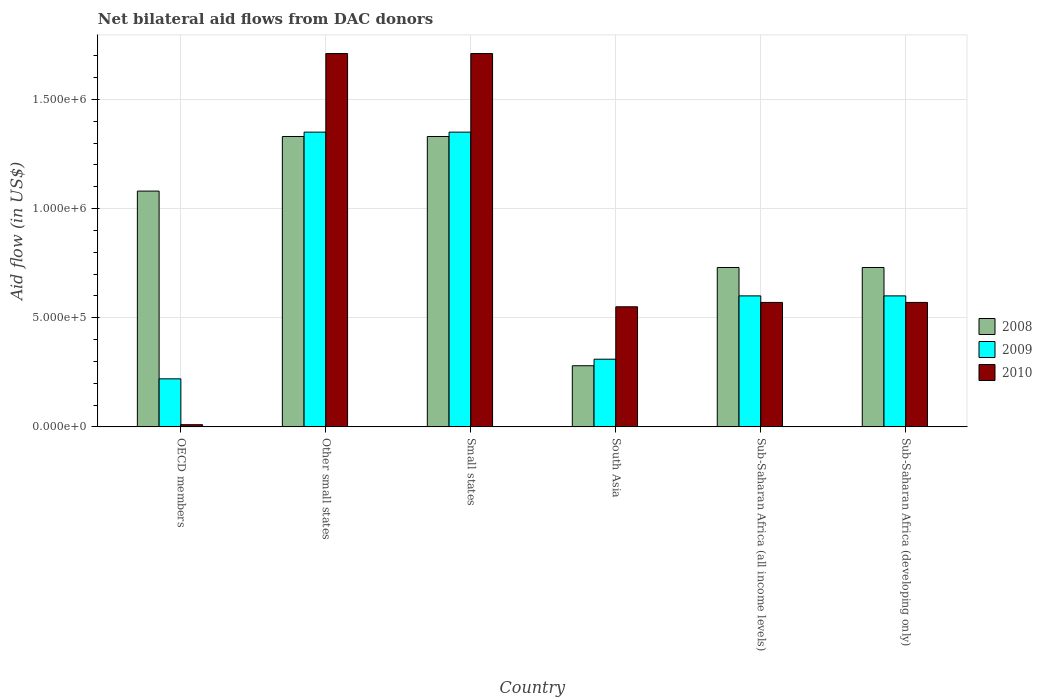How many different coloured bars are there?
Provide a succinct answer. 3. Are the number of bars per tick equal to the number of legend labels?
Offer a very short reply. Yes. How many bars are there on the 2nd tick from the right?
Keep it short and to the point. 3. What is the label of the 4th group of bars from the left?
Provide a succinct answer. South Asia. In how many cases, is the number of bars for a given country not equal to the number of legend labels?
Your response must be concise. 0. What is the net bilateral aid flow in 2008 in Small states?
Offer a very short reply. 1.33e+06. Across all countries, what is the maximum net bilateral aid flow in 2009?
Offer a very short reply. 1.35e+06. In which country was the net bilateral aid flow in 2008 maximum?
Your answer should be compact. Other small states. What is the total net bilateral aid flow in 2010 in the graph?
Keep it short and to the point. 5.12e+06. What is the difference between the net bilateral aid flow in 2010 in Other small states and that in Sub-Saharan Africa (all income levels)?
Provide a short and direct response. 1.14e+06. What is the difference between the net bilateral aid flow in 2010 in Sub-Saharan Africa (all income levels) and the net bilateral aid flow in 2009 in South Asia?
Your response must be concise. 2.60e+05. What is the average net bilateral aid flow in 2010 per country?
Your response must be concise. 8.53e+05. What is the difference between the net bilateral aid flow of/in 2010 and net bilateral aid flow of/in 2008 in Sub-Saharan Africa (developing only)?
Provide a short and direct response. -1.60e+05. In how many countries, is the net bilateral aid flow in 2010 greater than 1300000 US$?
Give a very brief answer. 2. What is the ratio of the net bilateral aid flow in 2010 in OECD members to that in Sub-Saharan Africa (developing only)?
Ensure brevity in your answer.  0.02. Is the difference between the net bilateral aid flow in 2010 in Small states and Sub-Saharan Africa (developing only) greater than the difference between the net bilateral aid flow in 2008 in Small states and Sub-Saharan Africa (developing only)?
Offer a very short reply. Yes. What is the difference between the highest and the second highest net bilateral aid flow in 2010?
Make the answer very short. 1.14e+06. What is the difference between the highest and the lowest net bilateral aid flow in 2009?
Keep it short and to the point. 1.13e+06. Is the sum of the net bilateral aid flow in 2010 in OECD members and Other small states greater than the maximum net bilateral aid flow in 2009 across all countries?
Make the answer very short. Yes. What does the 3rd bar from the left in South Asia represents?
Your answer should be very brief. 2010. What does the 3rd bar from the right in OECD members represents?
Provide a succinct answer. 2008. Does the graph contain grids?
Provide a short and direct response. Yes. Where does the legend appear in the graph?
Your answer should be compact. Center right. How many legend labels are there?
Give a very brief answer. 3. What is the title of the graph?
Offer a terse response. Net bilateral aid flows from DAC donors. What is the label or title of the X-axis?
Your response must be concise. Country. What is the label or title of the Y-axis?
Provide a succinct answer. Aid flow (in US$). What is the Aid flow (in US$) of 2008 in OECD members?
Keep it short and to the point. 1.08e+06. What is the Aid flow (in US$) of 2009 in OECD members?
Provide a short and direct response. 2.20e+05. What is the Aid flow (in US$) in 2010 in OECD members?
Keep it short and to the point. 10000. What is the Aid flow (in US$) in 2008 in Other small states?
Provide a short and direct response. 1.33e+06. What is the Aid flow (in US$) of 2009 in Other small states?
Ensure brevity in your answer.  1.35e+06. What is the Aid flow (in US$) in 2010 in Other small states?
Give a very brief answer. 1.71e+06. What is the Aid flow (in US$) of 2008 in Small states?
Your answer should be compact. 1.33e+06. What is the Aid flow (in US$) in 2009 in Small states?
Offer a very short reply. 1.35e+06. What is the Aid flow (in US$) in 2010 in Small states?
Keep it short and to the point. 1.71e+06. What is the Aid flow (in US$) in 2009 in South Asia?
Keep it short and to the point. 3.10e+05. What is the Aid flow (in US$) in 2008 in Sub-Saharan Africa (all income levels)?
Give a very brief answer. 7.30e+05. What is the Aid flow (in US$) in 2010 in Sub-Saharan Africa (all income levels)?
Your response must be concise. 5.70e+05. What is the Aid flow (in US$) of 2008 in Sub-Saharan Africa (developing only)?
Your answer should be compact. 7.30e+05. What is the Aid flow (in US$) of 2009 in Sub-Saharan Africa (developing only)?
Your response must be concise. 6.00e+05. What is the Aid flow (in US$) of 2010 in Sub-Saharan Africa (developing only)?
Your answer should be compact. 5.70e+05. Across all countries, what is the maximum Aid flow (in US$) in 2008?
Provide a succinct answer. 1.33e+06. Across all countries, what is the maximum Aid flow (in US$) in 2009?
Your answer should be very brief. 1.35e+06. Across all countries, what is the maximum Aid flow (in US$) of 2010?
Provide a short and direct response. 1.71e+06. Across all countries, what is the minimum Aid flow (in US$) in 2009?
Ensure brevity in your answer.  2.20e+05. Across all countries, what is the minimum Aid flow (in US$) in 2010?
Provide a succinct answer. 10000. What is the total Aid flow (in US$) of 2008 in the graph?
Provide a short and direct response. 5.48e+06. What is the total Aid flow (in US$) in 2009 in the graph?
Provide a short and direct response. 4.43e+06. What is the total Aid flow (in US$) in 2010 in the graph?
Offer a very short reply. 5.12e+06. What is the difference between the Aid flow (in US$) in 2008 in OECD members and that in Other small states?
Your response must be concise. -2.50e+05. What is the difference between the Aid flow (in US$) in 2009 in OECD members and that in Other small states?
Provide a succinct answer. -1.13e+06. What is the difference between the Aid flow (in US$) in 2010 in OECD members and that in Other small states?
Offer a terse response. -1.70e+06. What is the difference between the Aid flow (in US$) in 2009 in OECD members and that in Small states?
Keep it short and to the point. -1.13e+06. What is the difference between the Aid flow (in US$) of 2010 in OECD members and that in Small states?
Provide a succinct answer. -1.70e+06. What is the difference between the Aid flow (in US$) of 2008 in OECD members and that in South Asia?
Your answer should be very brief. 8.00e+05. What is the difference between the Aid flow (in US$) in 2009 in OECD members and that in South Asia?
Provide a short and direct response. -9.00e+04. What is the difference between the Aid flow (in US$) in 2010 in OECD members and that in South Asia?
Provide a short and direct response. -5.40e+05. What is the difference between the Aid flow (in US$) of 2008 in OECD members and that in Sub-Saharan Africa (all income levels)?
Make the answer very short. 3.50e+05. What is the difference between the Aid flow (in US$) of 2009 in OECD members and that in Sub-Saharan Africa (all income levels)?
Offer a terse response. -3.80e+05. What is the difference between the Aid flow (in US$) in 2010 in OECD members and that in Sub-Saharan Africa (all income levels)?
Keep it short and to the point. -5.60e+05. What is the difference between the Aid flow (in US$) of 2009 in OECD members and that in Sub-Saharan Africa (developing only)?
Provide a short and direct response. -3.80e+05. What is the difference between the Aid flow (in US$) of 2010 in OECD members and that in Sub-Saharan Africa (developing only)?
Ensure brevity in your answer.  -5.60e+05. What is the difference between the Aid flow (in US$) of 2008 in Other small states and that in Small states?
Your answer should be compact. 0. What is the difference between the Aid flow (in US$) of 2008 in Other small states and that in South Asia?
Keep it short and to the point. 1.05e+06. What is the difference between the Aid flow (in US$) in 2009 in Other small states and that in South Asia?
Keep it short and to the point. 1.04e+06. What is the difference between the Aid flow (in US$) in 2010 in Other small states and that in South Asia?
Give a very brief answer. 1.16e+06. What is the difference between the Aid flow (in US$) of 2008 in Other small states and that in Sub-Saharan Africa (all income levels)?
Ensure brevity in your answer.  6.00e+05. What is the difference between the Aid flow (in US$) of 2009 in Other small states and that in Sub-Saharan Africa (all income levels)?
Your response must be concise. 7.50e+05. What is the difference between the Aid flow (in US$) of 2010 in Other small states and that in Sub-Saharan Africa (all income levels)?
Provide a short and direct response. 1.14e+06. What is the difference between the Aid flow (in US$) in 2008 in Other small states and that in Sub-Saharan Africa (developing only)?
Provide a succinct answer. 6.00e+05. What is the difference between the Aid flow (in US$) in 2009 in Other small states and that in Sub-Saharan Africa (developing only)?
Offer a very short reply. 7.50e+05. What is the difference between the Aid flow (in US$) of 2010 in Other small states and that in Sub-Saharan Africa (developing only)?
Keep it short and to the point. 1.14e+06. What is the difference between the Aid flow (in US$) of 2008 in Small states and that in South Asia?
Your answer should be very brief. 1.05e+06. What is the difference between the Aid flow (in US$) in 2009 in Small states and that in South Asia?
Make the answer very short. 1.04e+06. What is the difference between the Aid flow (in US$) in 2010 in Small states and that in South Asia?
Your answer should be compact. 1.16e+06. What is the difference between the Aid flow (in US$) in 2008 in Small states and that in Sub-Saharan Africa (all income levels)?
Your answer should be very brief. 6.00e+05. What is the difference between the Aid flow (in US$) in 2009 in Small states and that in Sub-Saharan Africa (all income levels)?
Your response must be concise. 7.50e+05. What is the difference between the Aid flow (in US$) of 2010 in Small states and that in Sub-Saharan Africa (all income levels)?
Keep it short and to the point. 1.14e+06. What is the difference between the Aid flow (in US$) of 2008 in Small states and that in Sub-Saharan Africa (developing only)?
Your response must be concise. 6.00e+05. What is the difference between the Aid flow (in US$) in 2009 in Small states and that in Sub-Saharan Africa (developing only)?
Provide a succinct answer. 7.50e+05. What is the difference between the Aid flow (in US$) in 2010 in Small states and that in Sub-Saharan Africa (developing only)?
Provide a short and direct response. 1.14e+06. What is the difference between the Aid flow (in US$) in 2008 in South Asia and that in Sub-Saharan Africa (all income levels)?
Give a very brief answer. -4.50e+05. What is the difference between the Aid flow (in US$) in 2010 in South Asia and that in Sub-Saharan Africa (all income levels)?
Provide a short and direct response. -2.00e+04. What is the difference between the Aid flow (in US$) in 2008 in South Asia and that in Sub-Saharan Africa (developing only)?
Provide a short and direct response. -4.50e+05. What is the difference between the Aid flow (in US$) of 2009 in South Asia and that in Sub-Saharan Africa (developing only)?
Provide a succinct answer. -2.90e+05. What is the difference between the Aid flow (in US$) in 2010 in South Asia and that in Sub-Saharan Africa (developing only)?
Offer a terse response. -2.00e+04. What is the difference between the Aid flow (in US$) in 2008 in Sub-Saharan Africa (all income levels) and that in Sub-Saharan Africa (developing only)?
Ensure brevity in your answer.  0. What is the difference between the Aid flow (in US$) in 2009 in Sub-Saharan Africa (all income levels) and that in Sub-Saharan Africa (developing only)?
Your answer should be compact. 0. What is the difference between the Aid flow (in US$) in 2008 in OECD members and the Aid flow (in US$) in 2009 in Other small states?
Keep it short and to the point. -2.70e+05. What is the difference between the Aid flow (in US$) in 2008 in OECD members and the Aid flow (in US$) in 2010 in Other small states?
Your answer should be compact. -6.30e+05. What is the difference between the Aid flow (in US$) in 2009 in OECD members and the Aid flow (in US$) in 2010 in Other small states?
Your answer should be compact. -1.49e+06. What is the difference between the Aid flow (in US$) in 2008 in OECD members and the Aid flow (in US$) in 2009 in Small states?
Give a very brief answer. -2.70e+05. What is the difference between the Aid flow (in US$) in 2008 in OECD members and the Aid flow (in US$) in 2010 in Small states?
Keep it short and to the point. -6.30e+05. What is the difference between the Aid flow (in US$) of 2009 in OECD members and the Aid flow (in US$) of 2010 in Small states?
Keep it short and to the point. -1.49e+06. What is the difference between the Aid flow (in US$) in 2008 in OECD members and the Aid flow (in US$) in 2009 in South Asia?
Give a very brief answer. 7.70e+05. What is the difference between the Aid flow (in US$) of 2008 in OECD members and the Aid flow (in US$) of 2010 in South Asia?
Make the answer very short. 5.30e+05. What is the difference between the Aid flow (in US$) of 2009 in OECD members and the Aid flow (in US$) of 2010 in South Asia?
Your response must be concise. -3.30e+05. What is the difference between the Aid flow (in US$) in 2008 in OECD members and the Aid flow (in US$) in 2010 in Sub-Saharan Africa (all income levels)?
Your answer should be compact. 5.10e+05. What is the difference between the Aid flow (in US$) of 2009 in OECD members and the Aid flow (in US$) of 2010 in Sub-Saharan Africa (all income levels)?
Give a very brief answer. -3.50e+05. What is the difference between the Aid flow (in US$) in 2008 in OECD members and the Aid flow (in US$) in 2010 in Sub-Saharan Africa (developing only)?
Your answer should be compact. 5.10e+05. What is the difference between the Aid flow (in US$) in 2009 in OECD members and the Aid flow (in US$) in 2010 in Sub-Saharan Africa (developing only)?
Provide a succinct answer. -3.50e+05. What is the difference between the Aid flow (in US$) in 2008 in Other small states and the Aid flow (in US$) in 2009 in Small states?
Provide a short and direct response. -2.00e+04. What is the difference between the Aid flow (in US$) in 2008 in Other small states and the Aid flow (in US$) in 2010 in Small states?
Give a very brief answer. -3.80e+05. What is the difference between the Aid flow (in US$) in 2009 in Other small states and the Aid flow (in US$) in 2010 in Small states?
Your answer should be very brief. -3.60e+05. What is the difference between the Aid flow (in US$) in 2008 in Other small states and the Aid flow (in US$) in 2009 in South Asia?
Make the answer very short. 1.02e+06. What is the difference between the Aid flow (in US$) of 2008 in Other small states and the Aid flow (in US$) of 2010 in South Asia?
Ensure brevity in your answer.  7.80e+05. What is the difference between the Aid flow (in US$) in 2009 in Other small states and the Aid flow (in US$) in 2010 in South Asia?
Keep it short and to the point. 8.00e+05. What is the difference between the Aid flow (in US$) in 2008 in Other small states and the Aid flow (in US$) in 2009 in Sub-Saharan Africa (all income levels)?
Provide a succinct answer. 7.30e+05. What is the difference between the Aid flow (in US$) in 2008 in Other small states and the Aid flow (in US$) in 2010 in Sub-Saharan Africa (all income levels)?
Keep it short and to the point. 7.60e+05. What is the difference between the Aid flow (in US$) of 2009 in Other small states and the Aid flow (in US$) of 2010 in Sub-Saharan Africa (all income levels)?
Your response must be concise. 7.80e+05. What is the difference between the Aid flow (in US$) in 2008 in Other small states and the Aid flow (in US$) in 2009 in Sub-Saharan Africa (developing only)?
Your answer should be compact. 7.30e+05. What is the difference between the Aid flow (in US$) in 2008 in Other small states and the Aid flow (in US$) in 2010 in Sub-Saharan Africa (developing only)?
Give a very brief answer. 7.60e+05. What is the difference between the Aid flow (in US$) of 2009 in Other small states and the Aid flow (in US$) of 2010 in Sub-Saharan Africa (developing only)?
Keep it short and to the point. 7.80e+05. What is the difference between the Aid flow (in US$) of 2008 in Small states and the Aid flow (in US$) of 2009 in South Asia?
Provide a short and direct response. 1.02e+06. What is the difference between the Aid flow (in US$) of 2008 in Small states and the Aid flow (in US$) of 2010 in South Asia?
Give a very brief answer. 7.80e+05. What is the difference between the Aid flow (in US$) in 2009 in Small states and the Aid flow (in US$) in 2010 in South Asia?
Offer a very short reply. 8.00e+05. What is the difference between the Aid flow (in US$) of 2008 in Small states and the Aid flow (in US$) of 2009 in Sub-Saharan Africa (all income levels)?
Your answer should be compact. 7.30e+05. What is the difference between the Aid flow (in US$) of 2008 in Small states and the Aid flow (in US$) of 2010 in Sub-Saharan Africa (all income levels)?
Give a very brief answer. 7.60e+05. What is the difference between the Aid flow (in US$) in 2009 in Small states and the Aid flow (in US$) in 2010 in Sub-Saharan Africa (all income levels)?
Keep it short and to the point. 7.80e+05. What is the difference between the Aid flow (in US$) in 2008 in Small states and the Aid flow (in US$) in 2009 in Sub-Saharan Africa (developing only)?
Offer a very short reply. 7.30e+05. What is the difference between the Aid flow (in US$) in 2008 in Small states and the Aid flow (in US$) in 2010 in Sub-Saharan Africa (developing only)?
Give a very brief answer. 7.60e+05. What is the difference between the Aid flow (in US$) of 2009 in Small states and the Aid flow (in US$) of 2010 in Sub-Saharan Africa (developing only)?
Your answer should be very brief. 7.80e+05. What is the difference between the Aid flow (in US$) in 2008 in South Asia and the Aid flow (in US$) in 2009 in Sub-Saharan Africa (all income levels)?
Offer a very short reply. -3.20e+05. What is the difference between the Aid flow (in US$) of 2008 in South Asia and the Aid flow (in US$) of 2009 in Sub-Saharan Africa (developing only)?
Give a very brief answer. -3.20e+05. What is the difference between the Aid flow (in US$) in 2008 in South Asia and the Aid flow (in US$) in 2010 in Sub-Saharan Africa (developing only)?
Offer a terse response. -2.90e+05. What is the average Aid flow (in US$) of 2008 per country?
Provide a succinct answer. 9.13e+05. What is the average Aid flow (in US$) of 2009 per country?
Your response must be concise. 7.38e+05. What is the average Aid flow (in US$) of 2010 per country?
Your answer should be very brief. 8.53e+05. What is the difference between the Aid flow (in US$) of 2008 and Aid flow (in US$) of 2009 in OECD members?
Offer a very short reply. 8.60e+05. What is the difference between the Aid flow (in US$) of 2008 and Aid flow (in US$) of 2010 in OECD members?
Your response must be concise. 1.07e+06. What is the difference between the Aid flow (in US$) of 2008 and Aid flow (in US$) of 2009 in Other small states?
Your answer should be compact. -2.00e+04. What is the difference between the Aid flow (in US$) in 2008 and Aid flow (in US$) in 2010 in Other small states?
Make the answer very short. -3.80e+05. What is the difference between the Aid flow (in US$) in 2009 and Aid flow (in US$) in 2010 in Other small states?
Offer a terse response. -3.60e+05. What is the difference between the Aid flow (in US$) of 2008 and Aid flow (in US$) of 2009 in Small states?
Your answer should be very brief. -2.00e+04. What is the difference between the Aid flow (in US$) in 2008 and Aid flow (in US$) in 2010 in Small states?
Make the answer very short. -3.80e+05. What is the difference between the Aid flow (in US$) in 2009 and Aid flow (in US$) in 2010 in Small states?
Give a very brief answer. -3.60e+05. What is the difference between the Aid flow (in US$) in 2008 and Aid flow (in US$) in 2009 in South Asia?
Provide a succinct answer. -3.00e+04. What is the difference between the Aid flow (in US$) of 2008 and Aid flow (in US$) of 2010 in South Asia?
Offer a terse response. -2.70e+05. What is the difference between the Aid flow (in US$) of 2009 and Aid flow (in US$) of 2010 in South Asia?
Give a very brief answer. -2.40e+05. What is the difference between the Aid flow (in US$) of 2008 and Aid flow (in US$) of 2010 in Sub-Saharan Africa (developing only)?
Ensure brevity in your answer.  1.60e+05. What is the difference between the Aid flow (in US$) in 2009 and Aid flow (in US$) in 2010 in Sub-Saharan Africa (developing only)?
Give a very brief answer. 3.00e+04. What is the ratio of the Aid flow (in US$) in 2008 in OECD members to that in Other small states?
Provide a succinct answer. 0.81. What is the ratio of the Aid flow (in US$) of 2009 in OECD members to that in Other small states?
Your answer should be very brief. 0.16. What is the ratio of the Aid flow (in US$) of 2010 in OECD members to that in Other small states?
Your response must be concise. 0.01. What is the ratio of the Aid flow (in US$) of 2008 in OECD members to that in Small states?
Provide a short and direct response. 0.81. What is the ratio of the Aid flow (in US$) of 2009 in OECD members to that in Small states?
Give a very brief answer. 0.16. What is the ratio of the Aid flow (in US$) of 2010 in OECD members to that in Small states?
Your answer should be very brief. 0.01. What is the ratio of the Aid flow (in US$) in 2008 in OECD members to that in South Asia?
Make the answer very short. 3.86. What is the ratio of the Aid flow (in US$) of 2009 in OECD members to that in South Asia?
Give a very brief answer. 0.71. What is the ratio of the Aid flow (in US$) of 2010 in OECD members to that in South Asia?
Offer a very short reply. 0.02. What is the ratio of the Aid flow (in US$) in 2008 in OECD members to that in Sub-Saharan Africa (all income levels)?
Give a very brief answer. 1.48. What is the ratio of the Aid flow (in US$) of 2009 in OECD members to that in Sub-Saharan Africa (all income levels)?
Offer a very short reply. 0.37. What is the ratio of the Aid flow (in US$) of 2010 in OECD members to that in Sub-Saharan Africa (all income levels)?
Your response must be concise. 0.02. What is the ratio of the Aid flow (in US$) of 2008 in OECD members to that in Sub-Saharan Africa (developing only)?
Provide a succinct answer. 1.48. What is the ratio of the Aid flow (in US$) in 2009 in OECD members to that in Sub-Saharan Africa (developing only)?
Your answer should be compact. 0.37. What is the ratio of the Aid flow (in US$) in 2010 in OECD members to that in Sub-Saharan Africa (developing only)?
Your answer should be compact. 0.02. What is the ratio of the Aid flow (in US$) in 2009 in Other small states to that in Small states?
Your answer should be very brief. 1. What is the ratio of the Aid flow (in US$) in 2008 in Other small states to that in South Asia?
Provide a succinct answer. 4.75. What is the ratio of the Aid flow (in US$) of 2009 in Other small states to that in South Asia?
Give a very brief answer. 4.35. What is the ratio of the Aid flow (in US$) of 2010 in Other small states to that in South Asia?
Offer a terse response. 3.11. What is the ratio of the Aid flow (in US$) in 2008 in Other small states to that in Sub-Saharan Africa (all income levels)?
Ensure brevity in your answer.  1.82. What is the ratio of the Aid flow (in US$) in 2009 in Other small states to that in Sub-Saharan Africa (all income levels)?
Provide a succinct answer. 2.25. What is the ratio of the Aid flow (in US$) of 2010 in Other small states to that in Sub-Saharan Africa (all income levels)?
Make the answer very short. 3. What is the ratio of the Aid flow (in US$) of 2008 in Other small states to that in Sub-Saharan Africa (developing only)?
Provide a short and direct response. 1.82. What is the ratio of the Aid flow (in US$) in 2009 in Other small states to that in Sub-Saharan Africa (developing only)?
Provide a succinct answer. 2.25. What is the ratio of the Aid flow (in US$) of 2008 in Small states to that in South Asia?
Your response must be concise. 4.75. What is the ratio of the Aid flow (in US$) in 2009 in Small states to that in South Asia?
Your answer should be compact. 4.35. What is the ratio of the Aid flow (in US$) in 2010 in Small states to that in South Asia?
Provide a short and direct response. 3.11. What is the ratio of the Aid flow (in US$) of 2008 in Small states to that in Sub-Saharan Africa (all income levels)?
Offer a terse response. 1.82. What is the ratio of the Aid flow (in US$) of 2009 in Small states to that in Sub-Saharan Africa (all income levels)?
Offer a terse response. 2.25. What is the ratio of the Aid flow (in US$) in 2008 in Small states to that in Sub-Saharan Africa (developing only)?
Your answer should be compact. 1.82. What is the ratio of the Aid flow (in US$) in 2009 in Small states to that in Sub-Saharan Africa (developing only)?
Your response must be concise. 2.25. What is the ratio of the Aid flow (in US$) of 2010 in Small states to that in Sub-Saharan Africa (developing only)?
Keep it short and to the point. 3. What is the ratio of the Aid flow (in US$) of 2008 in South Asia to that in Sub-Saharan Africa (all income levels)?
Offer a very short reply. 0.38. What is the ratio of the Aid flow (in US$) of 2009 in South Asia to that in Sub-Saharan Africa (all income levels)?
Keep it short and to the point. 0.52. What is the ratio of the Aid flow (in US$) in 2010 in South Asia to that in Sub-Saharan Africa (all income levels)?
Ensure brevity in your answer.  0.96. What is the ratio of the Aid flow (in US$) in 2008 in South Asia to that in Sub-Saharan Africa (developing only)?
Offer a terse response. 0.38. What is the ratio of the Aid flow (in US$) in 2009 in South Asia to that in Sub-Saharan Africa (developing only)?
Offer a terse response. 0.52. What is the ratio of the Aid flow (in US$) of 2010 in South Asia to that in Sub-Saharan Africa (developing only)?
Your response must be concise. 0.96. What is the ratio of the Aid flow (in US$) of 2008 in Sub-Saharan Africa (all income levels) to that in Sub-Saharan Africa (developing only)?
Offer a terse response. 1. What is the ratio of the Aid flow (in US$) of 2009 in Sub-Saharan Africa (all income levels) to that in Sub-Saharan Africa (developing only)?
Make the answer very short. 1. What is the ratio of the Aid flow (in US$) in 2010 in Sub-Saharan Africa (all income levels) to that in Sub-Saharan Africa (developing only)?
Your answer should be very brief. 1. What is the difference between the highest and the lowest Aid flow (in US$) of 2008?
Ensure brevity in your answer.  1.05e+06. What is the difference between the highest and the lowest Aid flow (in US$) in 2009?
Offer a very short reply. 1.13e+06. What is the difference between the highest and the lowest Aid flow (in US$) in 2010?
Make the answer very short. 1.70e+06. 